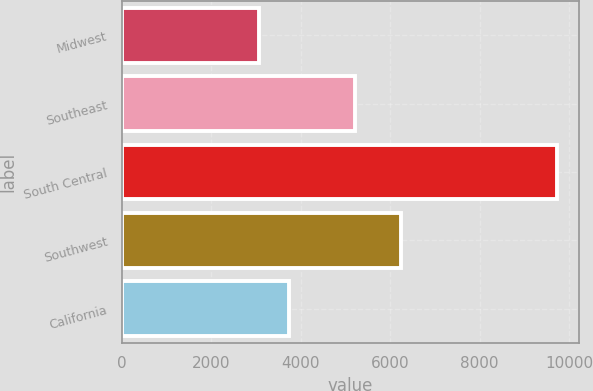Convert chart. <chart><loc_0><loc_0><loc_500><loc_500><bar_chart><fcel>Midwest<fcel>Southeast<fcel>South Central<fcel>Southwest<fcel>California<nl><fcel>3065<fcel>5206<fcel>9740<fcel>6244<fcel>3732.5<nl></chart> 